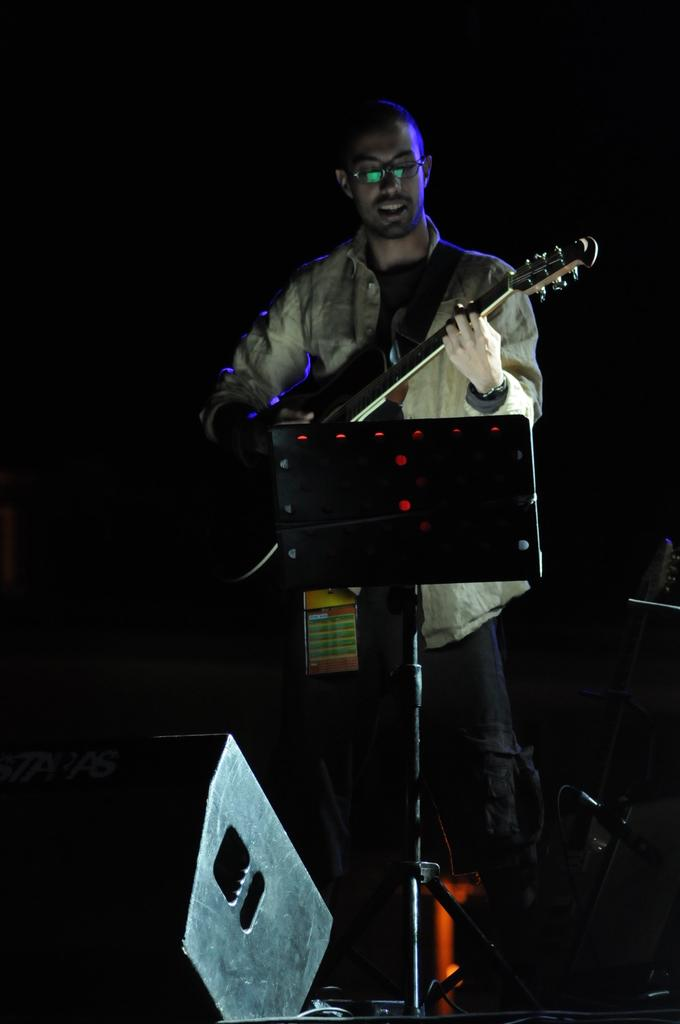What is the color of the background in the image? The background of the image is dark. Who is present in the image? There is a man in the image. What is the man wearing? The man is wearing spectacles. What is the man doing in the image? The man is playing a guitar. What object can be seen in front of the man? The man is standing in front of a podium. What other item is visible in the image? There is a device in the image. What type of grass is growing on the podium in the image? There is no grass present in the image, as the podium is a flat surface. 